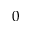<formula> <loc_0><loc_0><loc_500><loc_500>0</formula> 